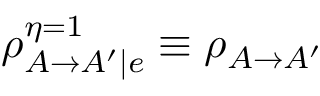Convert formula to latex. <formula><loc_0><loc_0><loc_500><loc_500>\rho _ { A \rightarrow A ^ { \prime } | e } ^ { \eta = 1 } \equiv \rho _ { A \rightarrow A ^ { \prime } }</formula> 